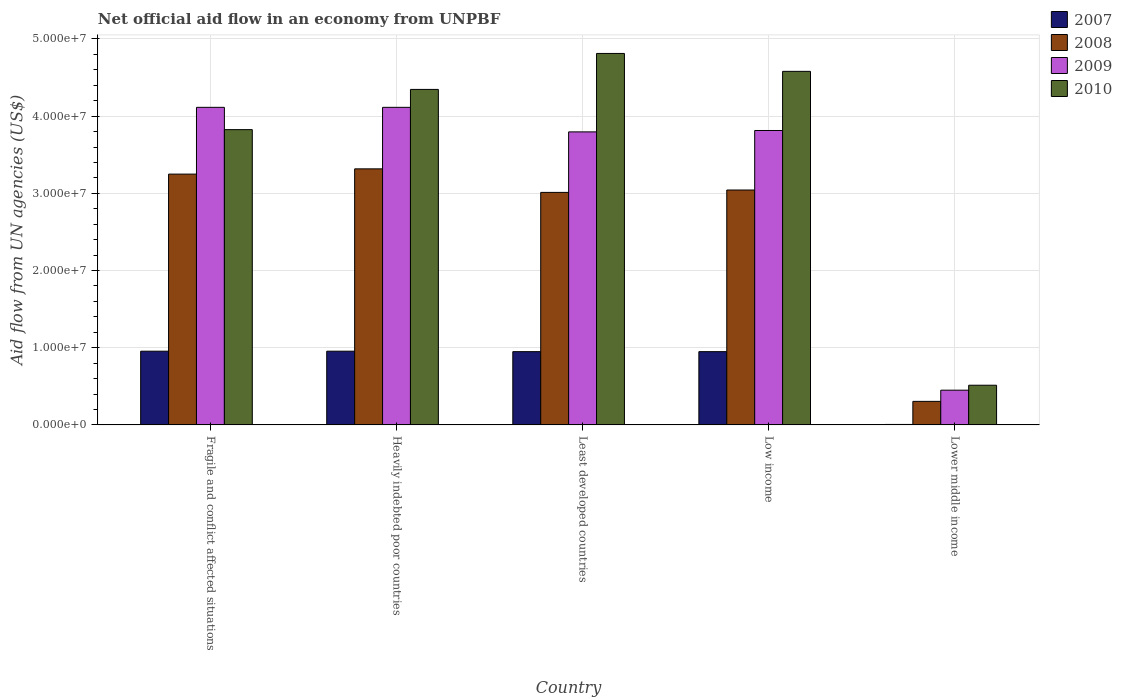How many different coloured bars are there?
Give a very brief answer. 4. How many groups of bars are there?
Your response must be concise. 5. How many bars are there on the 1st tick from the left?
Make the answer very short. 4. What is the label of the 3rd group of bars from the left?
Provide a short and direct response. Least developed countries. What is the net official aid flow in 2010 in Heavily indebted poor countries?
Give a very brief answer. 4.35e+07. Across all countries, what is the maximum net official aid flow in 2008?
Keep it short and to the point. 3.32e+07. Across all countries, what is the minimum net official aid flow in 2007?
Offer a terse response. 6.00e+04. In which country was the net official aid flow in 2008 maximum?
Your answer should be compact. Heavily indebted poor countries. In which country was the net official aid flow in 2010 minimum?
Provide a short and direct response. Lower middle income. What is the total net official aid flow in 2010 in the graph?
Your answer should be compact. 1.81e+08. What is the difference between the net official aid flow in 2010 in Least developed countries and that in Lower middle income?
Ensure brevity in your answer.  4.30e+07. What is the difference between the net official aid flow in 2007 in Lower middle income and the net official aid flow in 2009 in Heavily indebted poor countries?
Your answer should be compact. -4.11e+07. What is the average net official aid flow in 2009 per country?
Your answer should be very brief. 3.26e+07. What is the difference between the net official aid flow of/in 2007 and net official aid flow of/in 2009 in Low income?
Your response must be concise. -2.86e+07. In how many countries, is the net official aid flow in 2008 greater than 16000000 US$?
Keep it short and to the point. 4. What is the ratio of the net official aid flow in 2007 in Heavily indebted poor countries to that in Lower middle income?
Offer a very short reply. 159.17. What is the difference between the highest and the second highest net official aid flow in 2010?
Provide a short and direct response. 2.32e+06. What is the difference between the highest and the lowest net official aid flow in 2009?
Your response must be concise. 3.66e+07. Is the sum of the net official aid flow in 2008 in Fragile and conflict affected situations and Least developed countries greater than the maximum net official aid flow in 2009 across all countries?
Provide a succinct answer. Yes. Is it the case that in every country, the sum of the net official aid flow in 2009 and net official aid flow in 2007 is greater than the sum of net official aid flow in 2008 and net official aid flow in 2010?
Offer a very short reply. No. Is it the case that in every country, the sum of the net official aid flow in 2008 and net official aid flow in 2009 is greater than the net official aid flow in 2010?
Provide a succinct answer. Yes. How many bars are there?
Your answer should be very brief. 20. Are all the bars in the graph horizontal?
Ensure brevity in your answer.  No. How many countries are there in the graph?
Offer a terse response. 5. What is the difference between two consecutive major ticks on the Y-axis?
Ensure brevity in your answer.  1.00e+07. Are the values on the major ticks of Y-axis written in scientific E-notation?
Ensure brevity in your answer.  Yes. Does the graph contain any zero values?
Offer a very short reply. No. Where does the legend appear in the graph?
Make the answer very short. Top right. How many legend labels are there?
Give a very brief answer. 4. What is the title of the graph?
Offer a terse response. Net official aid flow in an economy from UNPBF. Does "2011" appear as one of the legend labels in the graph?
Provide a short and direct response. No. What is the label or title of the X-axis?
Your answer should be very brief. Country. What is the label or title of the Y-axis?
Provide a succinct answer. Aid flow from UN agencies (US$). What is the Aid flow from UN agencies (US$) in 2007 in Fragile and conflict affected situations?
Offer a terse response. 9.55e+06. What is the Aid flow from UN agencies (US$) of 2008 in Fragile and conflict affected situations?
Give a very brief answer. 3.25e+07. What is the Aid flow from UN agencies (US$) of 2009 in Fragile and conflict affected situations?
Offer a terse response. 4.11e+07. What is the Aid flow from UN agencies (US$) of 2010 in Fragile and conflict affected situations?
Give a very brief answer. 3.82e+07. What is the Aid flow from UN agencies (US$) of 2007 in Heavily indebted poor countries?
Your answer should be very brief. 9.55e+06. What is the Aid flow from UN agencies (US$) of 2008 in Heavily indebted poor countries?
Give a very brief answer. 3.32e+07. What is the Aid flow from UN agencies (US$) in 2009 in Heavily indebted poor countries?
Offer a terse response. 4.11e+07. What is the Aid flow from UN agencies (US$) in 2010 in Heavily indebted poor countries?
Give a very brief answer. 4.35e+07. What is the Aid flow from UN agencies (US$) in 2007 in Least developed countries?
Your answer should be very brief. 9.49e+06. What is the Aid flow from UN agencies (US$) in 2008 in Least developed countries?
Ensure brevity in your answer.  3.01e+07. What is the Aid flow from UN agencies (US$) in 2009 in Least developed countries?
Keep it short and to the point. 3.80e+07. What is the Aid flow from UN agencies (US$) of 2010 in Least developed countries?
Your response must be concise. 4.81e+07. What is the Aid flow from UN agencies (US$) in 2007 in Low income?
Keep it short and to the point. 9.49e+06. What is the Aid flow from UN agencies (US$) of 2008 in Low income?
Provide a short and direct response. 3.04e+07. What is the Aid flow from UN agencies (US$) in 2009 in Low income?
Ensure brevity in your answer.  3.81e+07. What is the Aid flow from UN agencies (US$) in 2010 in Low income?
Offer a terse response. 4.58e+07. What is the Aid flow from UN agencies (US$) of 2007 in Lower middle income?
Provide a short and direct response. 6.00e+04. What is the Aid flow from UN agencies (US$) of 2008 in Lower middle income?
Provide a short and direct response. 3.05e+06. What is the Aid flow from UN agencies (US$) of 2009 in Lower middle income?
Your response must be concise. 4.50e+06. What is the Aid flow from UN agencies (US$) of 2010 in Lower middle income?
Provide a succinct answer. 5.14e+06. Across all countries, what is the maximum Aid flow from UN agencies (US$) in 2007?
Your answer should be very brief. 9.55e+06. Across all countries, what is the maximum Aid flow from UN agencies (US$) of 2008?
Your answer should be very brief. 3.32e+07. Across all countries, what is the maximum Aid flow from UN agencies (US$) of 2009?
Your answer should be very brief. 4.11e+07. Across all countries, what is the maximum Aid flow from UN agencies (US$) in 2010?
Make the answer very short. 4.81e+07. Across all countries, what is the minimum Aid flow from UN agencies (US$) in 2007?
Offer a terse response. 6.00e+04. Across all countries, what is the minimum Aid flow from UN agencies (US$) in 2008?
Your answer should be compact. 3.05e+06. Across all countries, what is the minimum Aid flow from UN agencies (US$) of 2009?
Your answer should be very brief. 4.50e+06. Across all countries, what is the minimum Aid flow from UN agencies (US$) in 2010?
Your answer should be compact. 5.14e+06. What is the total Aid flow from UN agencies (US$) in 2007 in the graph?
Provide a succinct answer. 3.81e+07. What is the total Aid flow from UN agencies (US$) of 2008 in the graph?
Ensure brevity in your answer.  1.29e+08. What is the total Aid flow from UN agencies (US$) of 2009 in the graph?
Provide a succinct answer. 1.63e+08. What is the total Aid flow from UN agencies (US$) of 2010 in the graph?
Provide a short and direct response. 1.81e+08. What is the difference between the Aid flow from UN agencies (US$) in 2007 in Fragile and conflict affected situations and that in Heavily indebted poor countries?
Offer a terse response. 0. What is the difference between the Aid flow from UN agencies (US$) in 2008 in Fragile and conflict affected situations and that in Heavily indebted poor countries?
Your response must be concise. -6.80e+05. What is the difference between the Aid flow from UN agencies (US$) of 2009 in Fragile and conflict affected situations and that in Heavily indebted poor countries?
Give a very brief answer. 0. What is the difference between the Aid flow from UN agencies (US$) in 2010 in Fragile and conflict affected situations and that in Heavily indebted poor countries?
Ensure brevity in your answer.  -5.21e+06. What is the difference between the Aid flow from UN agencies (US$) of 2008 in Fragile and conflict affected situations and that in Least developed countries?
Provide a short and direct response. 2.37e+06. What is the difference between the Aid flow from UN agencies (US$) of 2009 in Fragile and conflict affected situations and that in Least developed countries?
Your response must be concise. 3.18e+06. What is the difference between the Aid flow from UN agencies (US$) in 2010 in Fragile and conflict affected situations and that in Least developed countries?
Offer a very short reply. -9.87e+06. What is the difference between the Aid flow from UN agencies (US$) in 2008 in Fragile and conflict affected situations and that in Low income?
Ensure brevity in your answer.  2.06e+06. What is the difference between the Aid flow from UN agencies (US$) in 2009 in Fragile and conflict affected situations and that in Low income?
Your answer should be very brief. 3.00e+06. What is the difference between the Aid flow from UN agencies (US$) of 2010 in Fragile and conflict affected situations and that in Low income?
Your answer should be very brief. -7.55e+06. What is the difference between the Aid flow from UN agencies (US$) of 2007 in Fragile and conflict affected situations and that in Lower middle income?
Offer a terse response. 9.49e+06. What is the difference between the Aid flow from UN agencies (US$) of 2008 in Fragile and conflict affected situations and that in Lower middle income?
Your response must be concise. 2.94e+07. What is the difference between the Aid flow from UN agencies (US$) in 2009 in Fragile and conflict affected situations and that in Lower middle income?
Make the answer very short. 3.66e+07. What is the difference between the Aid flow from UN agencies (US$) in 2010 in Fragile and conflict affected situations and that in Lower middle income?
Provide a succinct answer. 3.31e+07. What is the difference between the Aid flow from UN agencies (US$) in 2008 in Heavily indebted poor countries and that in Least developed countries?
Your answer should be compact. 3.05e+06. What is the difference between the Aid flow from UN agencies (US$) of 2009 in Heavily indebted poor countries and that in Least developed countries?
Offer a very short reply. 3.18e+06. What is the difference between the Aid flow from UN agencies (US$) of 2010 in Heavily indebted poor countries and that in Least developed countries?
Your answer should be very brief. -4.66e+06. What is the difference between the Aid flow from UN agencies (US$) in 2008 in Heavily indebted poor countries and that in Low income?
Your answer should be compact. 2.74e+06. What is the difference between the Aid flow from UN agencies (US$) of 2009 in Heavily indebted poor countries and that in Low income?
Your answer should be very brief. 3.00e+06. What is the difference between the Aid flow from UN agencies (US$) of 2010 in Heavily indebted poor countries and that in Low income?
Give a very brief answer. -2.34e+06. What is the difference between the Aid flow from UN agencies (US$) in 2007 in Heavily indebted poor countries and that in Lower middle income?
Keep it short and to the point. 9.49e+06. What is the difference between the Aid flow from UN agencies (US$) in 2008 in Heavily indebted poor countries and that in Lower middle income?
Your answer should be compact. 3.01e+07. What is the difference between the Aid flow from UN agencies (US$) of 2009 in Heavily indebted poor countries and that in Lower middle income?
Your response must be concise. 3.66e+07. What is the difference between the Aid flow from UN agencies (US$) of 2010 in Heavily indebted poor countries and that in Lower middle income?
Offer a terse response. 3.83e+07. What is the difference between the Aid flow from UN agencies (US$) of 2008 in Least developed countries and that in Low income?
Offer a terse response. -3.10e+05. What is the difference between the Aid flow from UN agencies (US$) in 2009 in Least developed countries and that in Low income?
Your response must be concise. -1.80e+05. What is the difference between the Aid flow from UN agencies (US$) in 2010 in Least developed countries and that in Low income?
Provide a succinct answer. 2.32e+06. What is the difference between the Aid flow from UN agencies (US$) of 2007 in Least developed countries and that in Lower middle income?
Give a very brief answer. 9.43e+06. What is the difference between the Aid flow from UN agencies (US$) in 2008 in Least developed countries and that in Lower middle income?
Your answer should be very brief. 2.71e+07. What is the difference between the Aid flow from UN agencies (US$) of 2009 in Least developed countries and that in Lower middle income?
Offer a very short reply. 3.35e+07. What is the difference between the Aid flow from UN agencies (US$) in 2010 in Least developed countries and that in Lower middle income?
Your response must be concise. 4.30e+07. What is the difference between the Aid flow from UN agencies (US$) of 2007 in Low income and that in Lower middle income?
Give a very brief answer. 9.43e+06. What is the difference between the Aid flow from UN agencies (US$) in 2008 in Low income and that in Lower middle income?
Provide a short and direct response. 2.74e+07. What is the difference between the Aid flow from UN agencies (US$) in 2009 in Low income and that in Lower middle income?
Keep it short and to the point. 3.36e+07. What is the difference between the Aid flow from UN agencies (US$) in 2010 in Low income and that in Lower middle income?
Ensure brevity in your answer.  4.07e+07. What is the difference between the Aid flow from UN agencies (US$) of 2007 in Fragile and conflict affected situations and the Aid flow from UN agencies (US$) of 2008 in Heavily indebted poor countries?
Offer a very short reply. -2.36e+07. What is the difference between the Aid flow from UN agencies (US$) in 2007 in Fragile and conflict affected situations and the Aid flow from UN agencies (US$) in 2009 in Heavily indebted poor countries?
Your answer should be compact. -3.16e+07. What is the difference between the Aid flow from UN agencies (US$) in 2007 in Fragile and conflict affected situations and the Aid flow from UN agencies (US$) in 2010 in Heavily indebted poor countries?
Give a very brief answer. -3.39e+07. What is the difference between the Aid flow from UN agencies (US$) in 2008 in Fragile and conflict affected situations and the Aid flow from UN agencies (US$) in 2009 in Heavily indebted poor countries?
Ensure brevity in your answer.  -8.65e+06. What is the difference between the Aid flow from UN agencies (US$) in 2008 in Fragile and conflict affected situations and the Aid flow from UN agencies (US$) in 2010 in Heavily indebted poor countries?
Your response must be concise. -1.10e+07. What is the difference between the Aid flow from UN agencies (US$) in 2009 in Fragile and conflict affected situations and the Aid flow from UN agencies (US$) in 2010 in Heavily indebted poor countries?
Ensure brevity in your answer.  -2.32e+06. What is the difference between the Aid flow from UN agencies (US$) of 2007 in Fragile and conflict affected situations and the Aid flow from UN agencies (US$) of 2008 in Least developed countries?
Give a very brief answer. -2.06e+07. What is the difference between the Aid flow from UN agencies (US$) in 2007 in Fragile and conflict affected situations and the Aid flow from UN agencies (US$) in 2009 in Least developed countries?
Your response must be concise. -2.84e+07. What is the difference between the Aid flow from UN agencies (US$) in 2007 in Fragile and conflict affected situations and the Aid flow from UN agencies (US$) in 2010 in Least developed countries?
Offer a terse response. -3.86e+07. What is the difference between the Aid flow from UN agencies (US$) in 2008 in Fragile and conflict affected situations and the Aid flow from UN agencies (US$) in 2009 in Least developed countries?
Offer a terse response. -5.47e+06. What is the difference between the Aid flow from UN agencies (US$) of 2008 in Fragile and conflict affected situations and the Aid flow from UN agencies (US$) of 2010 in Least developed countries?
Give a very brief answer. -1.56e+07. What is the difference between the Aid flow from UN agencies (US$) in 2009 in Fragile and conflict affected situations and the Aid flow from UN agencies (US$) in 2010 in Least developed countries?
Provide a short and direct response. -6.98e+06. What is the difference between the Aid flow from UN agencies (US$) of 2007 in Fragile and conflict affected situations and the Aid flow from UN agencies (US$) of 2008 in Low income?
Offer a very short reply. -2.09e+07. What is the difference between the Aid flow from UN agencies (US$) in 2007 in Fragile and conflict affected situations and the Aid flow from UN agencies (US$) in 2009 in Low income?
Ensure brevity in your answer.  -2.86e+07. What is the difference between the Aid flow from UN agencies (US$) in 2007 in Fragile and conflict affected situations and the Aid flow from UN agencies (US$) in 2010 in Low income?
Provide a short and direct response. -3.62e+07. What is the difference between the Aid flow from UN agencies (US$) of 2008 in Fragile and conflict affected situations and the Aid flow from UN agencies (US$) of 2009 in Low income?
Your answer should be very brief. -5.65e+06. What is the difference between the Aid flow from UN agencies (US$) of 2008 in Fragile and conflict affected situations and the Aid flow from UN agencies (US$) of 2010 in Low income?
Provide a short and direct response. -1.33e+07. What is the difference between the Aid flow from UN agencies (US$) in 2009 in Fragile and conflict affected situations and the Aid flow from UN agencies (US$) in 2010 in Low income?
Give a very brief answer. -4.66e+06. What is the difference between the Aid flow from UN agencies (US$) in 2007 in Fragile and conflict affected situations and the Aid flow from UN agencies (US$) in 2008 in Lower middle income?
Offer a terse response. 6.50e+06. What is the difference between the Aid flow from UN agencies (US$) in 2007 in Fragile and conflict affected situations and the Aid flow from UN agencies (US$) in 2009 in Lower middle income?
Give a very brief answer. 5.05e+06. What is the difference between the Aid flow from UN agencies (US$) of 2007 in Fragile and conflict affected situations and the Aid flow from UN agencies (US$) of 2010 in Lower middle income?
Your response must be concise. 4.41e+06. What is the difference between the Aid flow from UN agencies (US$) in 2008 in Fragile and conflict affected situations and the Aid flow from UN agencies (US$) in 2009 in Lower middle income?
Your response must be concise. 2.80e+07. What is the difference between the Aid flow from UN agencies (US$) of 2008 in Fragile and conflict affected situations and the Aid flow from UN agencies (US$) of 2010 in Lower middle income?
Offer a terse response. 2.74e+07. What is the difference between the Aid flow from UN agencies (US$) in 2009 in Fragile and conflict affected situations and the Aid flow from UN agencies (US$) in 2010 in Lower middle income?
Provide a short and direct response. 3.60e+07. What is the difference between the Aid flow from UN agencies (US$) in 2007 in Heavily indebted poor countries and the Aid flow from UN agencies (US$) in 2008 in Least developed countries?
Make the answer very short. -2.06e+07. What is the difference between the Aid flow from UN agencies (US$) of 2007 in Heavily indebted poor countries and the Aid flow from UN agencies (US$) of 2009 in Least developed countries?
Keep it short and to the point. -2.84e+07. What is the difference between the Aid flow from UN agencies (US$) of 2007 in Heavily indebted poor countries and the Aid flow from UN agencies (US$) of 2010 in Least developed countries?
Your answer should be compact. -3.86e+07. What is the difference between the Aid flow from UN agencies (US$) of 2008 in Heavily indebted poor countries and the Aid flow from UN agencies (US$) of 2009 in Least developed countries?
Your answer should be very brief. -4.79e+06. What is the difference between the Aid flow from UN agencies (US$) in 2008 in Heavily indebted poor countries and the Aid flow from UN agencies (US$) in 2010 in Least developed countries?
Offer a very short reply. -1.50e+07. What is the difference between the Aid flow from UN agencies (US$) in 2009 in Heavily indebted poor countries and the Aid flow from UN agencies (US$) in 2010 in Least developed countries?
Give a very brief answer. -6.98e+06. What is the difference between the Aid flow from UN agencies (US$) in 2007 in Heavily indebted poor countries and the Aid flow from UN agencies (US$) in 2008 in Low income?
Your answer should be compact. -2.09e+07. What is the difference between the Aid flow from UN agencies (US$) in 2007 in Heavily indebted poor countries and the Aid flow from UN agencies (US$) in 2009 in Low income?
Offer a terse response. -2.86e+07. What is the difference between the Aid flow from UN agencies (US$) in 2007 in Heavily indebted poor countries and the Aid flow from UN agencies (US$) in 2010 in Low income?
Make the answer very short. -3.62e+07. What is the difference between the Aid flow from UN agencies (US$) of 2008 in Heavily indebted poor countries and the Aid flow from UN agencies (US$) of 2009 in Low income?
Your answer should be compact. -4.97e+06. What is the difference between the Aid flow from UN agencies (US$) in 2008 in Heavily indebted poor countries and the Aid flow from UN agencies (US$) in 2010 in Low income?
Your response must be concise. -1.26e+07. What is the difference between the Aid flow from UN agencies (US$) of 2009 in Heavily indebted poor countries and the Aid flow from UN agencies (US$) of 2010 in Low income?
Your answer should be very brief. -4.66e+06. What is the difference between the Aid flow from UN agencies (US$) in 2007 in Heavily indebted poor countries and the Aid flow from UN agencies (US$) in 2008 in Lower middle income?
Make the answer very short. 6.50e+06. What is the difference between the Aid flow from UN agencies (US$) in 2007 in Heavily indebted poor countries and the Aid flow from UN agencies (US$) in 2009 in Lower middle income?
Your response must be concise. 5.05e+06. What is the difference between the Aid flow from UN agencies (US$) in 2007 in Heavily indebted poor countries and the Aid flow from UN agencies (US$) in 2010 in Lower middle income?
Offer a terse response. 4.41e+06. What is the difference between the Aid flow from UN agencies (US$) in 2008 in Heavily indebted poor countries and the Aid flow from UN agencies (US$) in 2009 in Lower middle income?
Offer a very short reply. 2.87e+07. What is the difference between the Aid flow from UN agencies (US$) in 2008 in Heavily indebted poor countries and the Aid flow from UN agencies (US$) in 2010 in Lower middle income?
Give a very brief answer. 2.80e+07. What is the difference between the Aid flow from UN agencies (US$) in 2009 in Heavily indebted poor countries and the Aid flow from UN agencies (US$) in 2010 in Lower middle income?
Provide a succinct answer. 3.60e+07. What is the difference between the Aid flow from UN agencies (US$) in 2007 in Least developed countries and the Aid flow from UN agencies (US$) in 2008 in Low income?
Keep it short and to the point. -2.09e+07. What is the difference between the Aid flow from UN agencies (US$) of 2007 in Least developed countries and the Aid flow from UN agencies (US$) of 2009 in Low income?
Provide a short and direct response. -2.86e+07. What is the difference between the Aid flow from UN agencies (US$) in 2007 in Least developed countries and the Aid flow from UN agencies (US$) in 2010 in Low income?
Provide a short and direct response. -3.63e+07. What is the difference between the Aid flow from UN agencies (US$) of 2008 in Least developed countries and the Aid flow from UN agencies (US$) of 2009 in Low income?
Make the answer very short. -8.02e+06. What is the difference between the Aid flow from UN agencies (US$) of 2008 in Least developed countries and the Aid flow from UN agencies (US$) of 2010 in Low income?
Ensure brevity in your answer.  -1.57e+07. What is the difference between the Aid flow from UN agencies (US$) in 2009 in Least developed countries and the Aid flow from UN agencies (US$) in 2010 in Low income?
Your answer should be very brief. -7.84e+06. What is the difference between the Aid flow from UN agencies (US$) in 2007 in Least developed countries and the Aid flow from UN agencies (US$) in 2008 in Lower middle income?
Offer a very short reply. 6.44e+06. What is the difference between the Aid flow from UN agencies (US$) in 2007 in Least developed countries and the Aid flow from UN agencies (US$) in 2009 in Lower middle income?
Give a very brief answer. 4.99e+06. What is the difference between the Aid flow from UN agencies (US$) in 2007 in Least developed countries and the Aid flow from UN agencies (US$) in 2010 in Lower middle income?
Provide a succinct answer. 4.35e+06. What is the difference between the Aid flow from UN agencies (US$) of 2008 in Least developed countries and the Aid flow from UN agencies (US$) of 2009 in Lower middle income?
Ensure brevity in your answer.  2.56e+07. What is the difference between the Aid flow from UN agencies (US$) in 2008 in Least developed countries and the Aid flow from UN agencies (US$) in 2010 in Lower middle income?
Give a very brief answer. 2.50e+07. What is the difference between the Aid flow from UN agencies (US$) in 2009 in Least developed countries and the Aid flow from UN agencies (US$) in 2010 in Lower middle income?
Keep it short and to the point. 3.28e+07. What is the difference between the Aid flow from UN agencies (US$) of 2007 in Low income and the Aid flow from UN agencies (US$) of 2008 in Lower middle income?
Provide a succinct answer. 6.44e+06. What is the difference between the Aid flow from UN agencies (US$) of 2007 in Low income and the Aid flow from UN agencies (US$) of 2009 in Lower middle income?
Make the answer very short. 4.99e+06. What is the difference between the Aid flow from UN agencies (US$) in 2007 in Low income and the Aid flow from UN agencies (US$) in 2010 in Lower middle income?
Your answer should be very brief. 4.35e+06. What is the difference between the Aid flow from UN agencies (US$) of 2008 in Low income and the Aid flow from UN agencies (US$) of 2009 in Lower middle income?
Your response must be concise. 2.59e+07. What is the difference between the Aid flow from UN agencies (US$) of 2008 in Low income and the Aid flow from UN agencies (US$) of 2010 in Lower middle income?
Your response must be concise. 2.53e+07. What is the difference between the Aid flow from UN agencies (US$) of 2009 in Low income and the Aid flow from UN agencies (US$) of 2010 in Lower middle income?
Ensure brevity in your answer.  3.30e+07. What is the average Aid flow from UN agencies (US$) of 2007 per country?
Ensure brevity in your answer.  7.63e+06. What is the average Aid flow from UN agencies (US$) in 2008 per country?
Offer a terse response. 2.59e+07. What is the average Aid flow from UN agencies (US$) in 2009 per country?
Provide a short and direct response. 3.26e+07. What is the average Aid flow from UN agencies (US$) in 2010 per country?
Your answer should be compact. 3.62e+07. What is the difference between the Aid flow from UN agencies (US$) of 2007 and Aid flow from UN agencies (US$) of 2008 in Fragile and conflict affected situations?
Provide a short and direct response. -2.29e+07. What is the difference between the Aid flow from UN agencies (US$) in 2007 and Aid flow from UN agencies (US$) in 2009 in Fragile and conflict affected situations?
Give a very brief answer. -3.16e+07. What is the difference between the Aid flow from UN agencies (US$) of 2007 and Aid flow from UN agencies (US$) of 2010 in Fragile and conflict affected situations?
Keep it short and to the point. -2.87e+07. What is the difference between the Aid flow from UN agencies (US$) in 2008 and Aid flow from UN agencies (US$) in 2009 in Fragile and conflict affected situations?
Provide a short and direct response. -8.65e+06. What is the difference between the Aid flow from UN agencies (US$) in 2008 and Aid flow from UN agencies (US$) in 2010 in Fragile and conflict affected situations?
Give a very brief answer. -5.76e+06. What is the difference between the Aid flow from UN agencies (US$) in 2009 and Aid flow from UN agencies (US$) in 2010 in Fragile and conflict affected situations?
Keep it short and to the point. 2.89e+06. What is the difference between the Aid flow from UN agencies (US$) in 2007 and Aid flow from UN agencies (US$) in 2008 in Heavily indebted poor countries?
Make the answer very short. -2.36e+07. What is the difference between the Aid flow from UN agencies (US$) of 2007 and Aid flow from UN agencies (US$) of 2009 in Heavily indebted poor countries?
Provide a short and direct response. -3.16e+07. What is the difference between the Aid flow from UN agencies (US$) in 2007 and Aid flow from UN agencies (US$) in 2010 in Heavily indebted poor countries?
Give a very brief answer. -3.39e+07. What is the difference between the Aid flow from UN agencies (US$) of 2008 and Aid flow from UN agencies (US$) of 2009 in Heavily indebted poor countries?
Your answer should be very brief. -7.97e+06. What is the difference between the Aid flow from UN agencies (US$) in 2008 and Aid flow from UN agencies (US$) in 2010 in Heavily indebted poor countries?
Your answer should be very brief. -1.03e+07. What is the difference between the Aid flow from UN agencies (US$) of 2009 and Aid flow from UN agencies (US$) of 2010 in Heavily indebted poor countries?
Your answer should be compact. -2.32e+06. What is the difference between the Aid flow from UN agencies (US$) in 2007 and Aid flow from UN agencies (US$) in 2008 in Least developed countries?
Make the answer very short. -2.06e+07. What is the difference between the Aid flow from UN agencies (US$) in 2007 and Aid flow from UN agencies (US$) in 2009 in Least developed countries?
Keep it short and to the point. -2.85e+07. What is the difference between the Aid flow from UN agencies (US$) of 2007 and Aid flow from UN agencies (US$) of 2010 in Least developed countries?
Your response must be concise. -3.86e+07. What is the difference between the Aid flow from UN agencies (US$) in 2008 and Aid flow from UN agencies (US$) in 2009 in Least developed countries?
Your answer should be compact. -7.84e+06. What is the difference between the Aid flow from UN agencies (US$) of 2008 and Aid flow from UN agencies (US$) of 2010 in Least developed countries?
Your answer should be compact. -1.80e+07. What is the difference between the Aid flow from UN agencies (US$) in 2009 and Aid flow from UN agencies (US$) in 2010 in Least developed countries?
Keep it short and to the point. -1.02e+07. What is the difference between the Aid flow from UN agencies (US$) of 2007 and Aid flow from UN agencies (US$) of 2008 in Low income?
Provide a succinct answer. -2.09e+07. What is the difference between the Aid flow from UN agencies (US$) of 2007 and Aid flow from UN agencies (US$) of 2009 in Low income?
Your response must be concise. -2.86e+07. What is the difference between the Aid flow from UN agencies (US$) of 2007 and Aid flow from UN agencies (US$) of 2010 in Low income?
Your answer should be very brief. -3.63e+07. What is the difference between the Aid flow from UN agencies (US$) in 2008 and Aid flow from UN agencies (US$) in 2009 in Low income?
Offer a terse response. -7.71e+06. What is the difference between the Aid flow from UN agencies (US$) in 2008 and Aid flow from UN agencies (US$) in 2010 in Low income?
Keep it short and to the point. -1.54e+07. What is the difference between the Aid flow from UN agencies (US$) in 2009 and Aid flow from UN agencies (US$) in 2010 in Low income?
Offer a very short reply. -7.66e+06. What is the difference between the Aid flow from UN agencies (US$) of 2007 and Aid flow from UN agencies (US$) of 2008 in Lower middle income?
Your response must be concise. -2.99e+06. What is the difference between the Aid flow from UN agencies (US$) in 2007 and Aid flow from UN agencies (US$) in 2009 in Lower middle income?
Your answer should be very brief. -4.44e+06. What is the difference between the Aid flow from UN agencies (US$) of 2007 and Aid flow from UN agencies (US$) of 2010 in Lower middle income?
Offer a very short reply. -5.08e+06. What is the difference between the Aid flow from UN agencies (US$) of 2008 and Aid flow from UN agencies (US$) of 2009 in Lower middle income?
Give a very brief answer. -1.45e+06. What is the difference between the Aid flow from UN agencies (US$) in 2008 and Aid flow from UN agencies (US$) in 2010 in Lower middle income?
Provide a succinct answer. -2.09e+06. What is the difference between the Aid flow from UN agencies (US$) in 2009 and Aid flow from UN agencies (US$) in 2010 in Lower middle income?
Your answer should be compact. -6.40e+05. What is the ratio of the Aid flow from UN agencies (US$) in 2007 in Fragile and conflict affected situations to that in Heavily indebted poor countries?
Offer a terse response. 1. What is the ratio of the Aid flow from UN agencies (US$) of 2008 in Fragile and conflict affected situations to that in Heavily indebted poor countries?
Provide a succinct answer. 0.98. What is the ratio of the Aid flow from UN agencies (US$) in 2009 in Fragile and conflict affected situations to that in Heavily indebted poor countries?
Provide a short and direct response. 1. What is the ratio of the Aid flow from UN agencies (US$) in 2010 in Fragile and conflict affected situations to that in Heavily indebted poor countries?
Provide a succinct answer. 0.88. What is the ratio of the Aid flow from UN agencies (US$) of 2007 in Fragile and conflict affected situations to that in Least developed countries?
Make the answer very short. 1.01. What is the ratio of the Aid flow from UN agencies (US$) in 2008 in Fragile and conflict affected situations to that in Least developed countries?
Your answer should be very brief. 1.08. What is the ratio of the Aid flow from UN agencies (US$) of 2009 in Fragile and conflict affected situations to that in Least developed countries?
Give a very brief answer. 1.08. What is the ratio of the Aid flow from UN agencies (US$) in 2010 in Fragile and conflict affected situations to that in Least developed countries?
Provide a succinct answer. 0.79. What is the ratio of the Aid flow from UN agencies (US$) in 2008 in Fragile and conflict affected situations to that in Low income?
Offer a very short reply. 1.07. What is the ratio of the Aid flow from UN agencies (US$) of 2009 in Fragile and conflict affected situations to that in Low income?
Offer a terse response. 1.08. What is the ratio of the Aid flow from UN agencies (US$) in 2010 in Fragile and conflict affected situations to that in Low income?
Provide a succinct answer. 0.84. What is the ratio of the Aid flow from UN agencies (US$) in 2007 in Fragile and conflict affected situations to that in Lower middle income?
Offer a very short reply. 159.17. What is the ratio of the Aid flow from UN agencies (US$) in 2008 in Fragile and conflict affected situations to that in Lower middle income?
Provide a short and direct response. 10.65. What is the ratio of the Aid flow from UN agencies (US$) of 2009 in Fragile and conflict affected situations to that in Lower middle income?
Your response must be concise. 9.14. What is the ratio of the Aid flow from UN agencies (US$) in 2010 in Fragile and conflict affected situations to that in Lower middle income?
Give a very brief answer. 7.44. What is the ratio of the Aid flow from UN agencies (US$) in 2008 in Heavily indebted poor countries to that in Least developed countries?
Give a very brief answer. 1.1. What is the ratio of the Aid flow from UN agencies (US$) in 2009 in Heavily indebted poor countries to that in Least developed countries?
Provide a succinct answer. 1.08. What is the ratio of the Aid flow from UN agencies (US$) of 2010 in Heavily indebted poor countries to that in Least developed countries?
Give a very brief answer. 0.9. What is the ratio of the Aid flow from UN agencies (US$) of 2008 in Heavily indebted poor countries to that in Low income?
Your answer should be compact. 1.09. What is the ratio of the Aid flow from UN agencies (US$) of 2009 in Heavily indebted poor countries to that in Low income?
Provide a short and direct response. 1.08. What is the ratio of the Aid flow from UN agencies (US$) of 2010 in Heavily indebted poor countries to that in Low income?
Provide a succinct answer. 0.95. What is the ratio of the Aid flow from UN agencies (US$) of 2007 in Heavily indebted poor countries to that in Lower middle income?
Offer a very short reply. 159.17. What is the ratio of the Aid flow from UN agencies (US$) in 2008 in Heavily indebted poor countries to that in Lower middle income?
Your answer should be compact. 10.88. What is the ratio of the Aid flow from UN agencies (US$) in 2009 in Heavily indebted poor countries to that in Lower middle income?
Your answer should be very brief. 9.14. What is the ratio of the Aid flow from UN agencies (US$) in 2010 in Heavily indebted poor countries to that in Lower middle income?
Make the answer very short. 8.46. What is the ratio of the Aid flow from UN agencies (US$) in 2010 in Least developed countries to that in Low income?
Your answer should be very brief. 1.05. What is the ratio of the Aid flow from UN agencies (US$) in 2007 in Least developed countries to that in Lower middle income?
Offer a very short reply. 158.17. What is the ratio of the Aid flow from UN agencies (US$) of 2008 in Least developed countries to that in Lower middle income?
Ensure brevity in your answer.  9.88. What is the ratio of the Aid flow from UN agencies (US$) in 2009 in Least developed countries to that in Lower middle income?
Your answer should be very brief. 8.44. What is the ratio of the Aid flow from UN agencies (US$) of 2010 in Least developed countries to that in Lower middle income?
Make the answer very short. 9.36. What is the ratio of the Aid flow from UN agencies (US$) of 2007 in Low income to that in Lower middle income?
Offer a terse response. 158.17. What is the ratio of the Aid flow from UN agencies (US$) in 2008 in Low income to that in Lower middle income?
Ensure brevity in your answer.  9.98. What is the ratio of the Aid flow from UN agencies (US$) in 2009 in Low income to that in Lower middle income?
Your answer should be compact. 8.48. What is the ratio of the Aid flow from UN agencies (US$) in 2010 in Low income to that in Lower middle income?
Give a very brief answer. 8.91. What is the difference between the highest and the second highest Aid flow from UN agencies (US$) in 2008?
Keep it short and to the point. 6.80e+05. What is the difference between the highest and the second highest Aid flow from UN agencies (US$) of 2010?
Ensure brevity in your answer.  2.32e+06. What is the difference between the highest and the lowest Aid flow from UN agencies (US$) of 2007?
Your response must be concise. 9.49e+06. What is the difference between the highest and the lowest Aid flow from UN agencies (US$) of 2008?
Make the answer very short. 3.01e+07. What is the difference between the highest and the lowest Aid flow from UN agencies (US$) of 2009?
Your answer should be very brief. 3.66e+07. What is the difference between the highest and the lowest Aid flow from UN agencies (US$) of 2010?
Provide a short and direct response. 4.30e+07. 